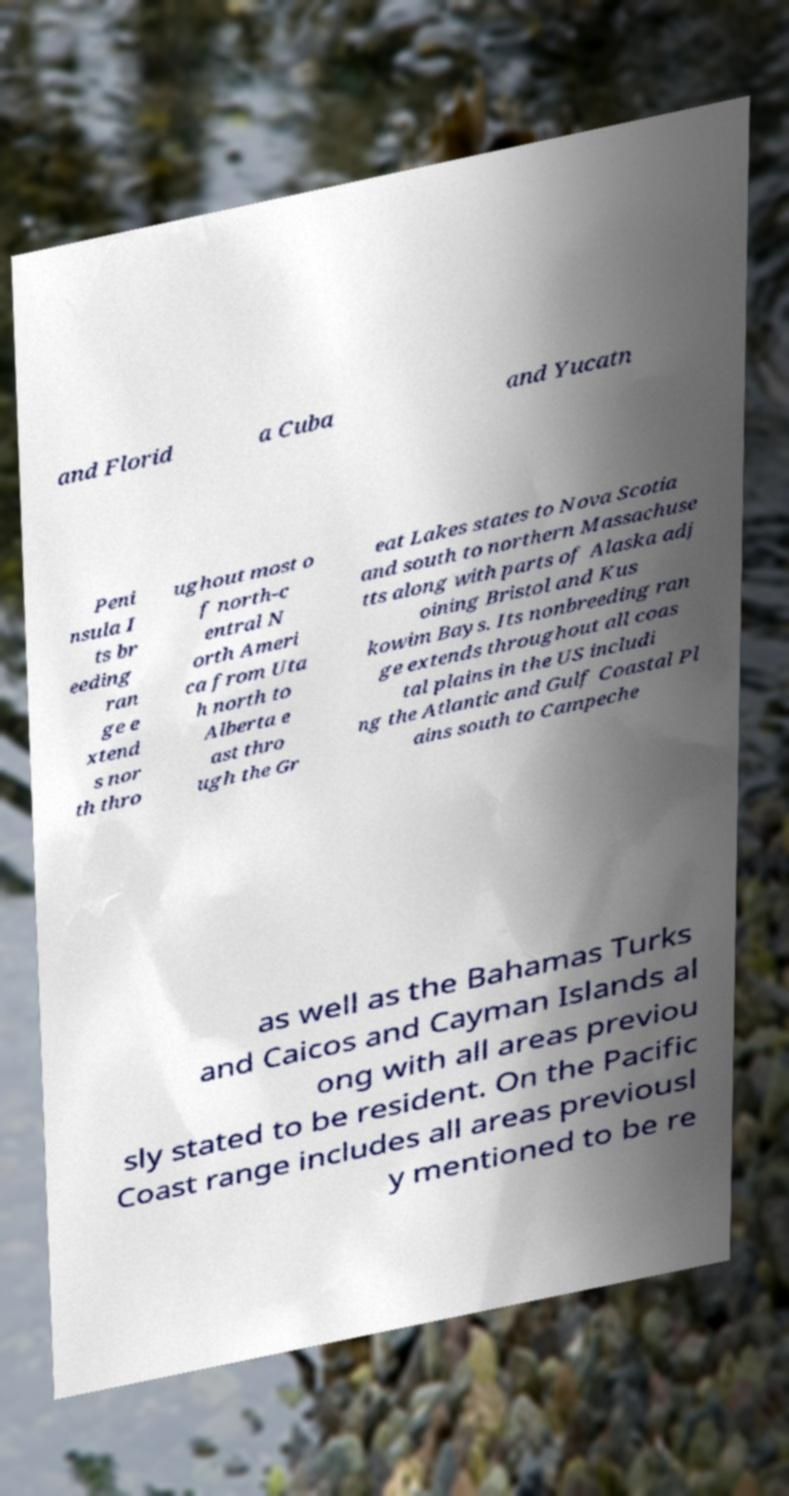Please identify and transcribe the text found in this image. and Florid a Cuba and Yucatn Peni nsula I ts br eeding ran ge e xtend s nor th thro ughout most o f north-c entral N orth Ameri ca from Uta h north to Alberta e ast thro ugh the Gr eat Lakes states to Nova Scotia and south to northern Massachuse tts along with parts of Alaska adj oining Bristol and Kus kowim Bays. Its nonbreeding ran ge extends throughout all coas tal plains in the US includi ng the Atlantic and Gulf Coastal Pl ains south to Campeche as well as the Bahamas Turks and Caicos and Cayman Islands al ong with all areas previou sly stated to be resident. On the Pacific Coast range includes all areas previousl y mentioned to be re 